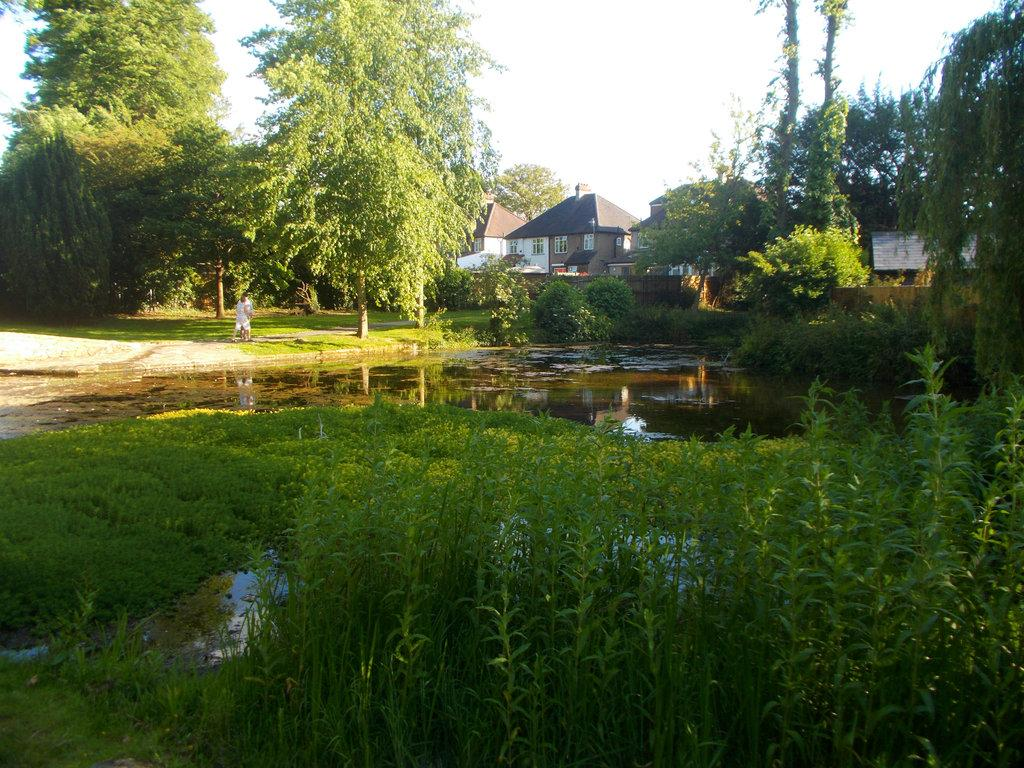What type of vegetation is at the bottom of the image? There is grass at the bottom of the image. What else can be seen in the image besides grass? There is water visible in the image. What can be seen in the background of the image? There are trees and a house in the background of the image. What is visible at the top of the image? The sky is visible at the top of the image. What type of plantation is shown in the image? There is no plantation present in the image. Can you tell me how many people are shown crushing something in the image? There are no people shown crushing anything in the image. 